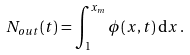<formula> <loc_0><loc_0><loc_500><loc_500>N _ { o u t } ( t ) = \int ^ { x _ { m } } _ { 1 } \phi ( x , t ) \, { \mathrm d } x \, .</formula> 